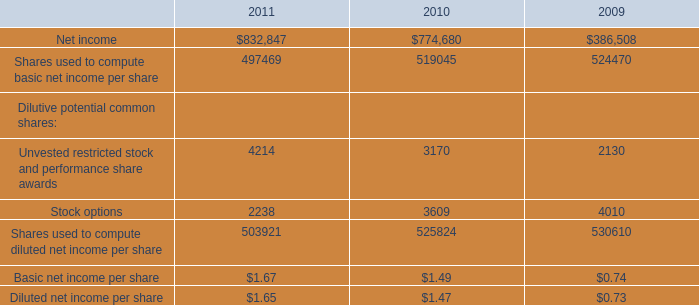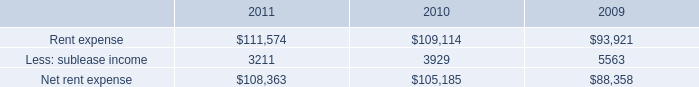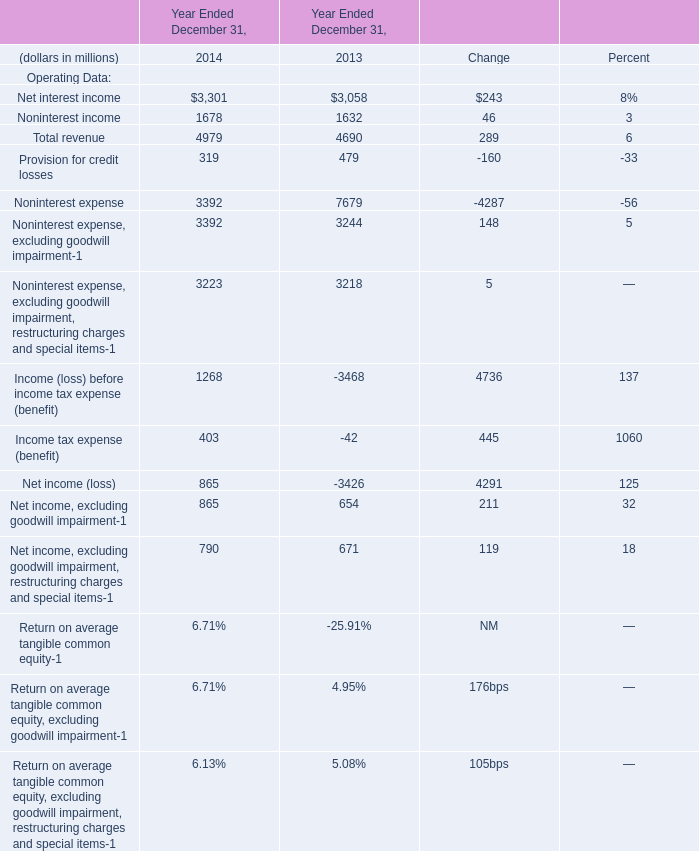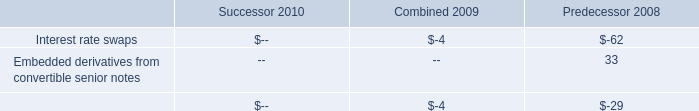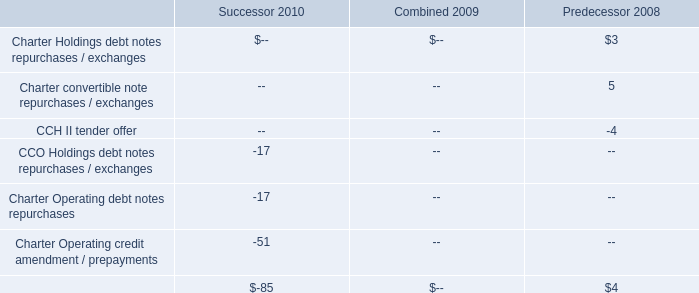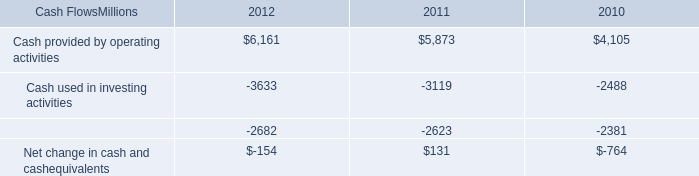what was the average cost per locomotive for the 2012 early buyout? 
Computations: ((75 * 1000000) / 165)
Answer: 454545.45455. 